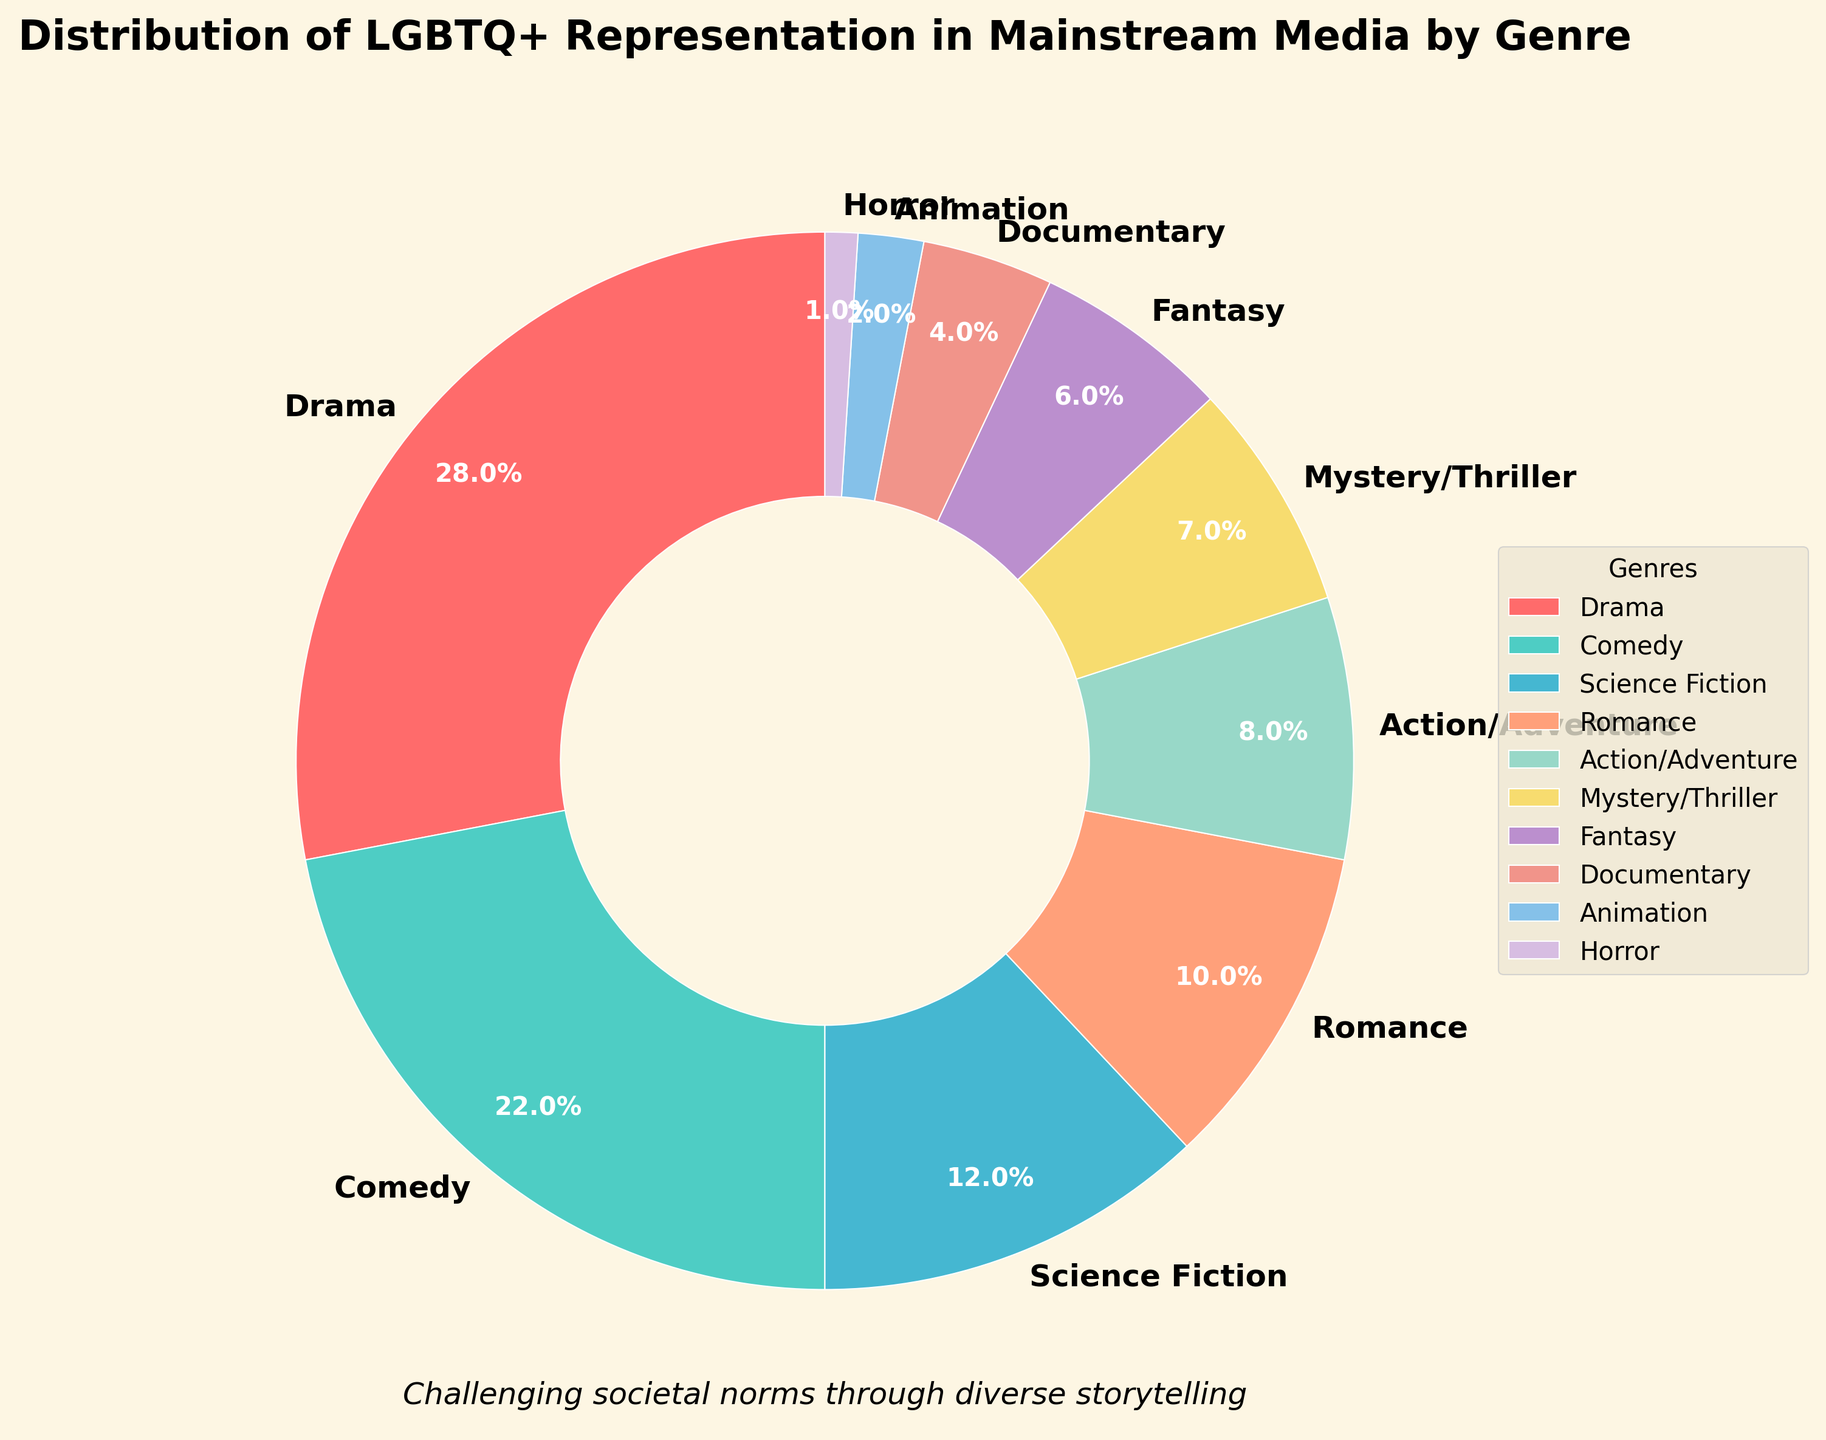What genre has the highest representation of LGBTQ+ characters? By inspecting the pie chart, we can see that the Drama genre segment is the largest.
Answer: Drama Which genre has a higher percentage of LGBTQ+ representation, Comedy or Science Fiction? By comparing the respective segments in the pie chart, Comedy has 22% while Science Fiction has 12%.
Answer: Comedy What is the total representation percentage for Romance, Action/Adventure, and Horror combined? By adding the percentages for these genres: 10% (Romance) + 8% (Action/Adventure) + 1% (Horror) = 19%.
Answer: 19% Is the representation in the Animation genre less than that in the Documentary genre? According to the pie chart, Animation has 2% representation, and Documentary has 4%, so yes, Animation has less representation.
Answer: Yes What is the difference in representation percentage between the Fantasy and Mystery/Thriller genres? By subtracting the percentages: 7% (Mystery/Thriller) - 6% (Fantasy) = 1%.
Answer: 1% Which genres have less than 5% representation of LGBTQ+ characters? The segments with less than 5% representation include Documentary (4%), Animation (2%), and Horror (1%).
Answer: Documentary, Animation, Horror What are the three genres with the highest LGBTQ+ representation? By observing the largest segments of the pie chart, the three top genres are Drama (28%), Comedy (22%), and Science Fiction (12%).
Answer: Drama, Comedy, Science Fiction Calculate the average representation percentage of Action/Adventure, Mystery/Thriller, and Fantasy genres. Sum the percentages (8% + 7% + 6%) = 21%, then divide by the number of genres: 21% / 3 = 7%.
Answer: 7% How much more percentage representation does Drama have compared to Romance? Subtract Romance's percentage from Drama's: 28% - 10% = 18%.
Answer: 18% Which genre has the lowest LGBTQ+ representation in mainstream media? The smallest segment in the pie chart represents Horror, with 1% representation.
Answer: Horror 